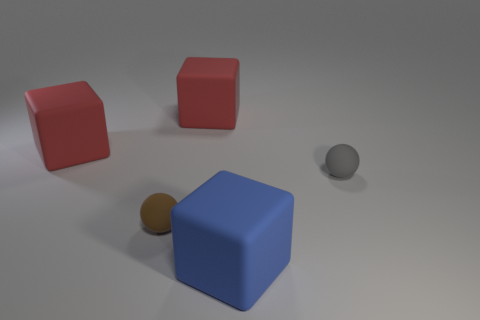Are there more large things right of the tiny brown ball than blue rubber objects that are to the right of the small gray rubber thing?
Your response must be concise. Yes. The thing that is both right of the brown matte sphere and behind the tiny gray rubber sphere has what shape?
Provide a succinct answer. Cube. There is a small object that is made of the same material as the brown ball; what is its shape?
Your answer should be very brief. Sphere. Are there any purple shiny spheres?
Keep it short and to the point. No. Is there a tiny sphere on the right side of the red rubber block on the right side of the small brown thing?
Keep it short and to the point. Yes. There is another small object that is the same shape as the brown thing; what is its material?
Offer a very short reply. Rubber. Are there more tiny brown matte balls than large cubes?
Offer a terse response. No. The matte thing that is both to the right of the tiny brown thing and to the left of the blue matte block is what color?
Offer a very short reply. Red. Are there fewer small matte balls than small gray metallic cubes?
Your answer should be very brief. No. There is a red object that is on the left side of the brown sphere; what shape is it?
Offer a terse response. Cube. 